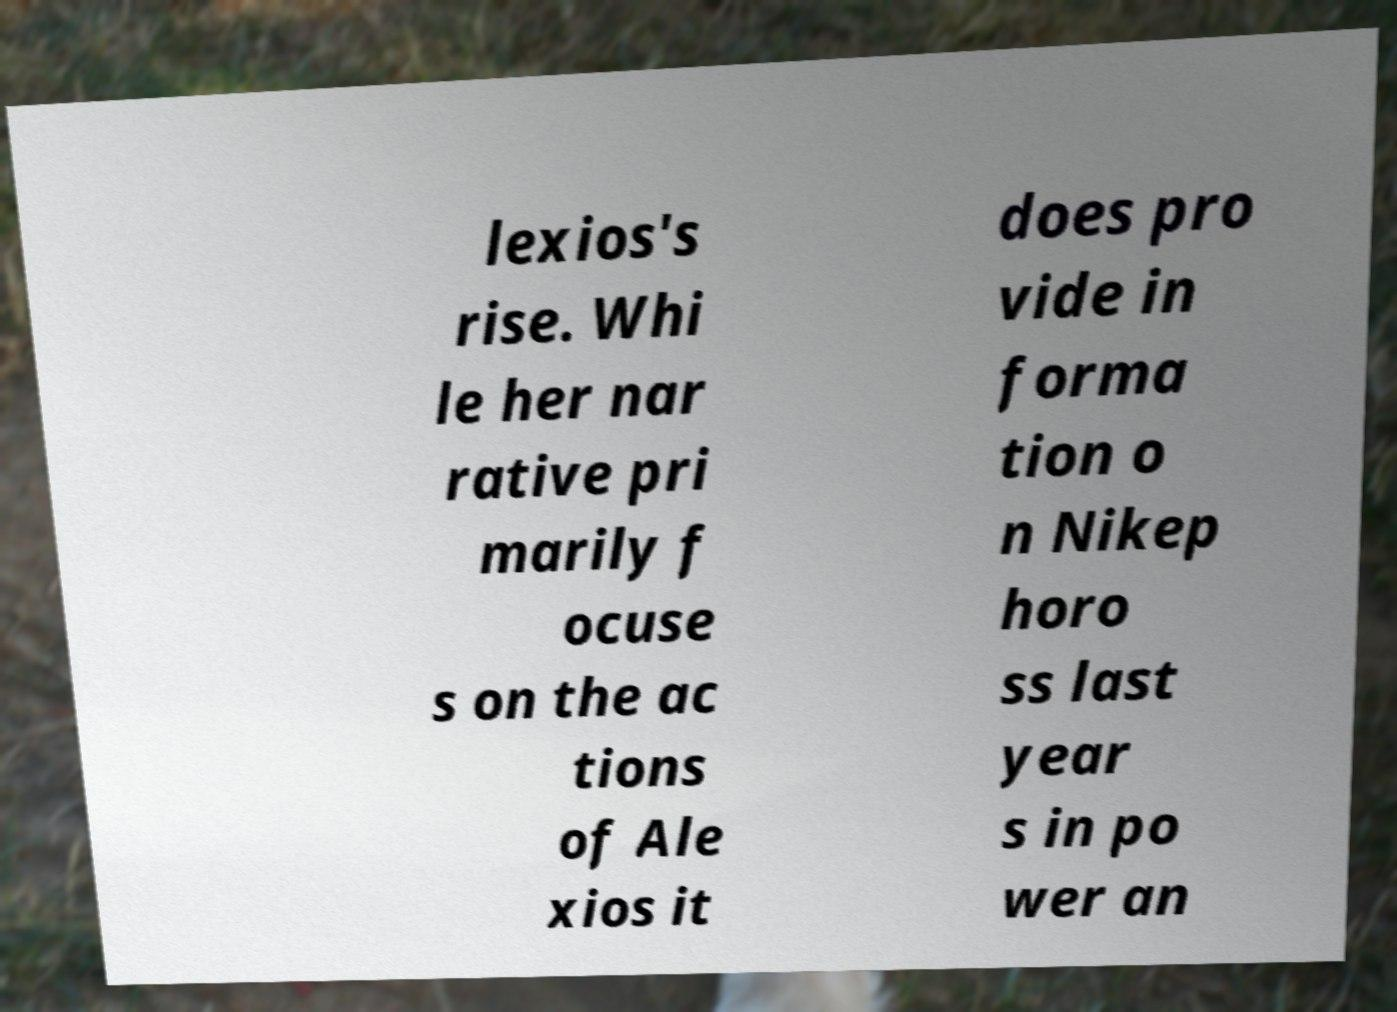Can you read and provide the text displayed in the image?This photo seems to have some interesting text. Can you extract and type it out for me? lexios's rise. Whi le her nar rative pri marily f ocuse s on the ac tions of Ale xios it does pro vide in forma tion o n Nikep horo ss last year s in po wer an 